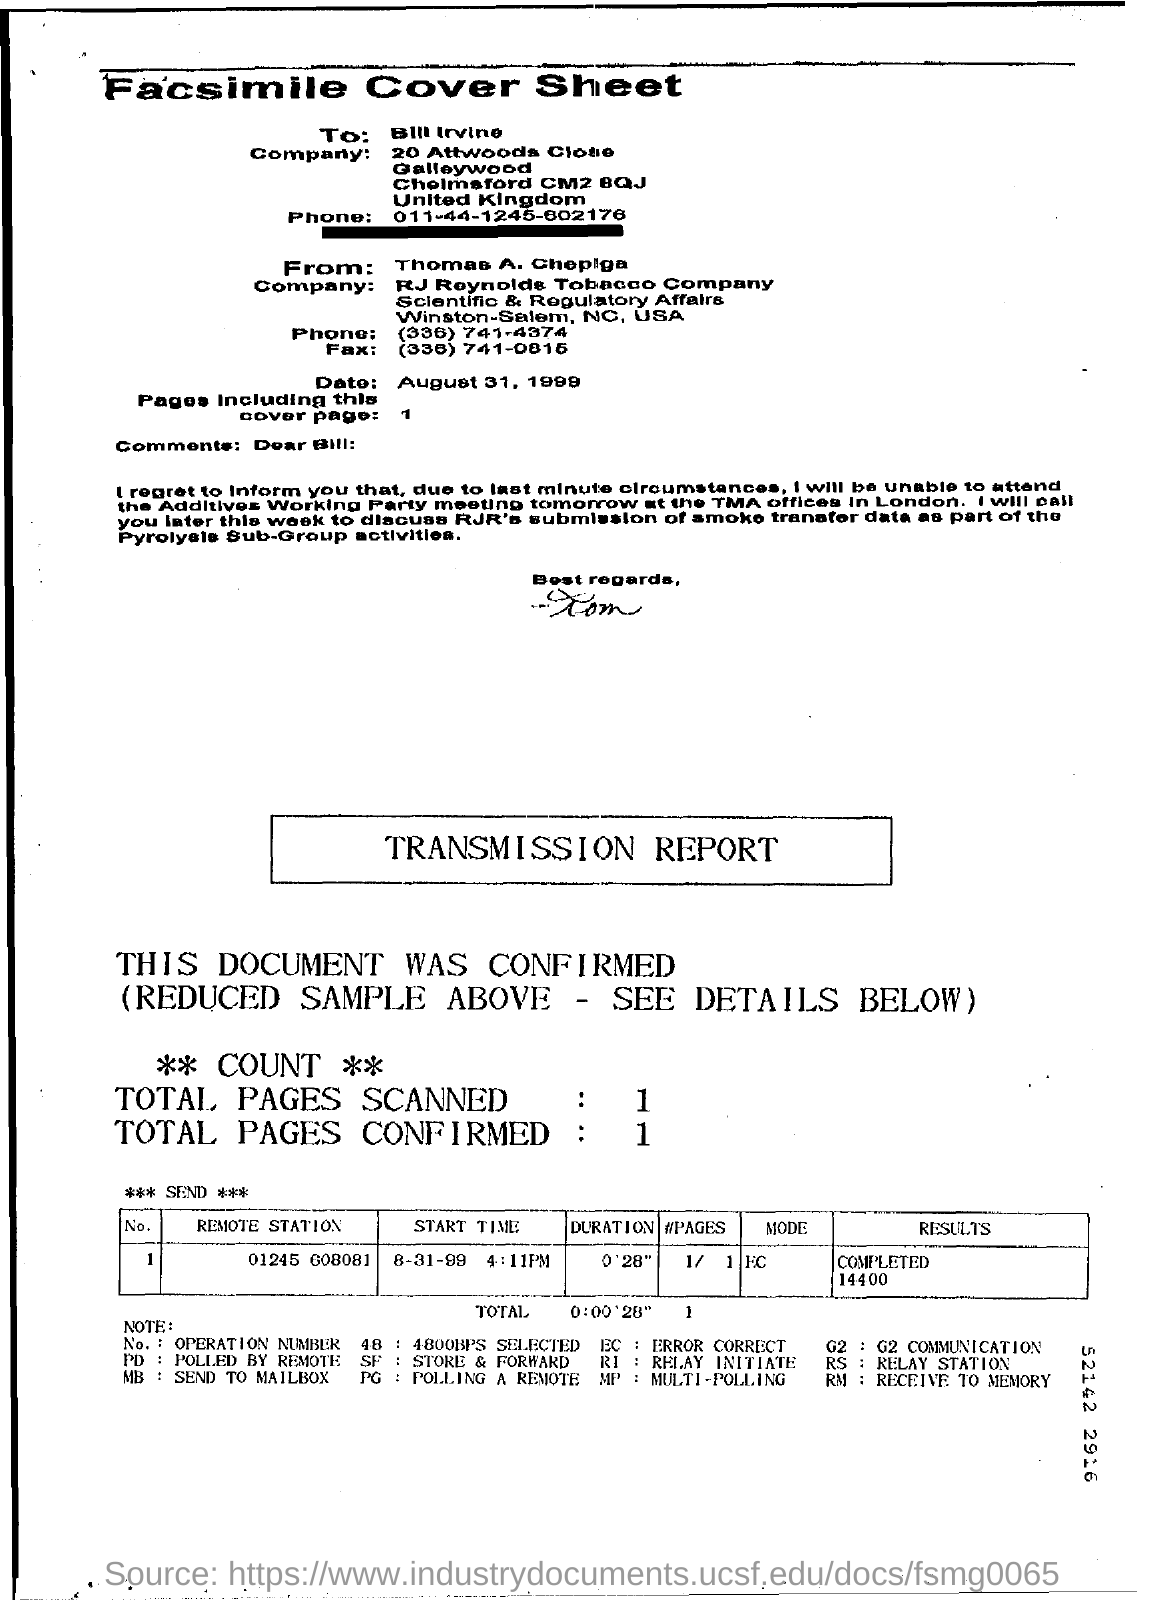To Whom is this Fax addressed to?
Offer a very short reply. Bill Irvine. What is the Date?
Offer a very short reply. August 31, 1999. What is the "start time" for "Remote station" "01245 608081"?
Keep it short and to the point. 8-31-99 4:11PM. What is the "Results" for "Remote station" "01245 608081"?
Provide a succinct answer. COMPLETED 14400. 